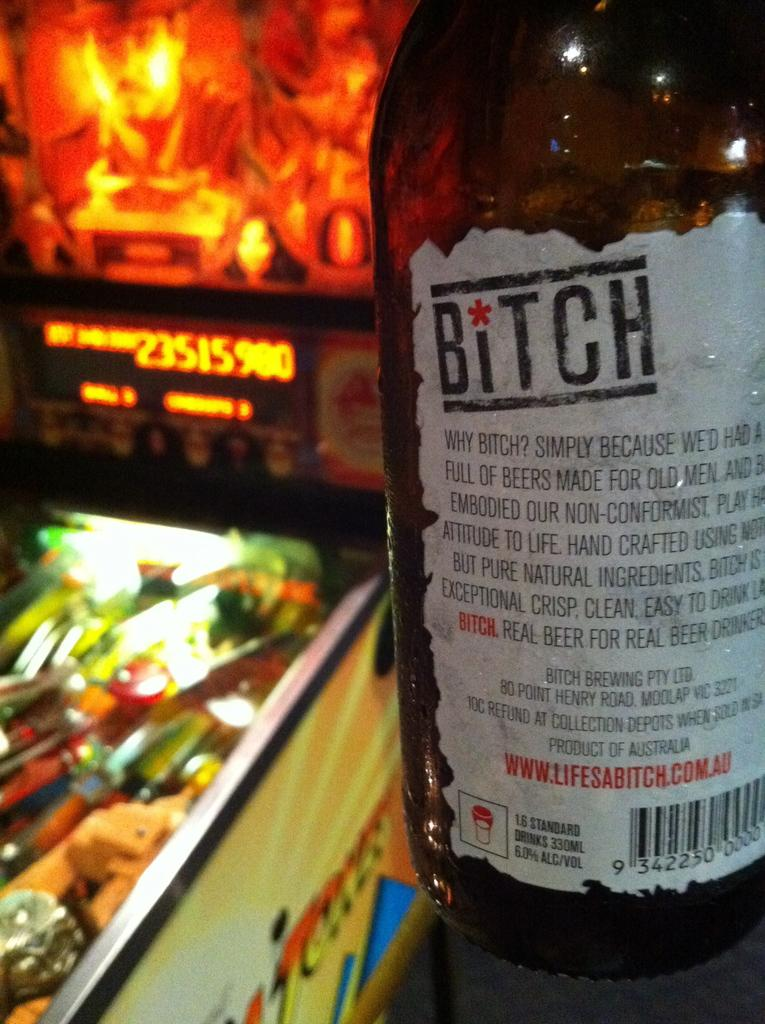<image>
Summarize the visual content of the image. Pinball machine with a Bitch Beer bottle on a shelf. 